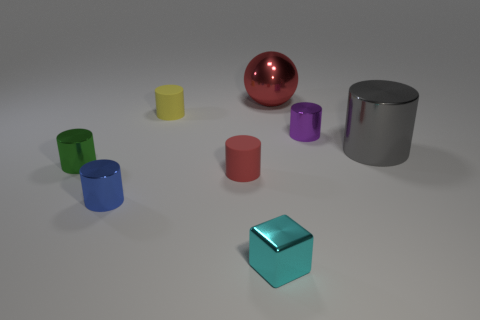Subtract all small red cylinders. How many cylinders are left? 5 Add 1 tiny metal cylinders. How many objects exist? 9 Subtract all gray cylinders. How many cylinders are left? 5 Subtract all cubes. How many objects are left? 7 Subtract 2 cylinders. How many cylinders are left? 4 Add 8 big red spheres. How many big red spheres are left? 9 Add 6 large cyan metal cylinders. How many large cyan metal cylinders exist? 6 Subtract 0 yellow blocks. How many objects are left? 8 Subtract all purple cylinders. Subtract all gray blocks. How many cylinders are left? 5 Subtract all green balls. How many blue cylinders are left? 1 